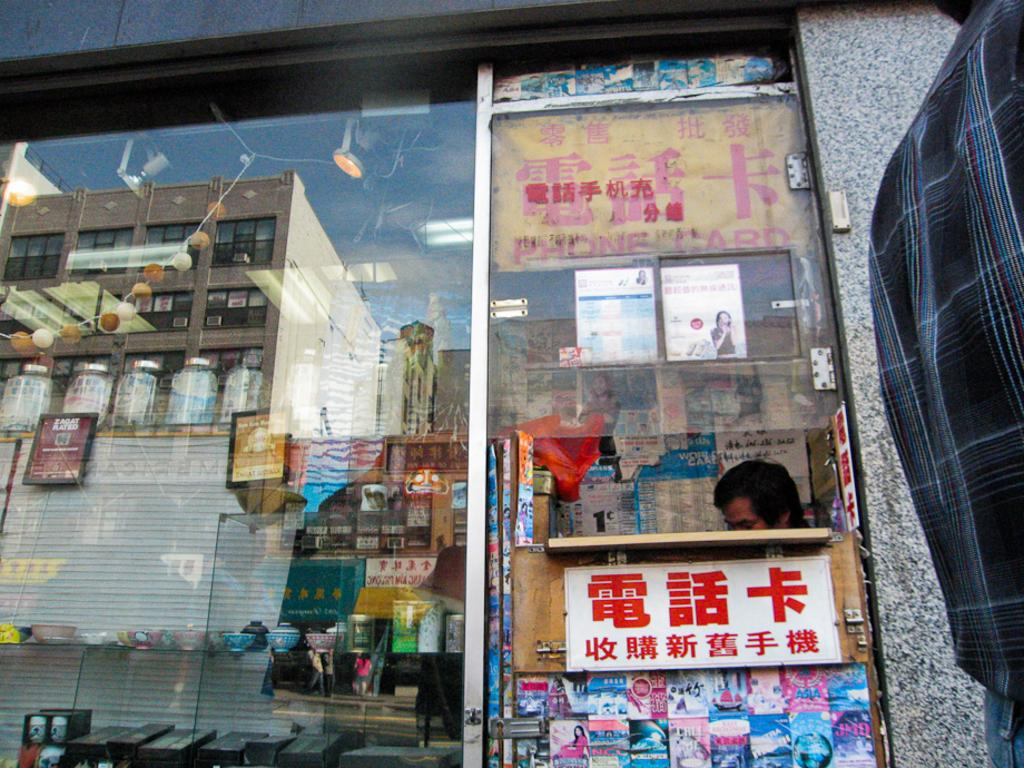<image>
Create a compact narrative representing the image presented. a kiosk front advertising phone card in Chinese 